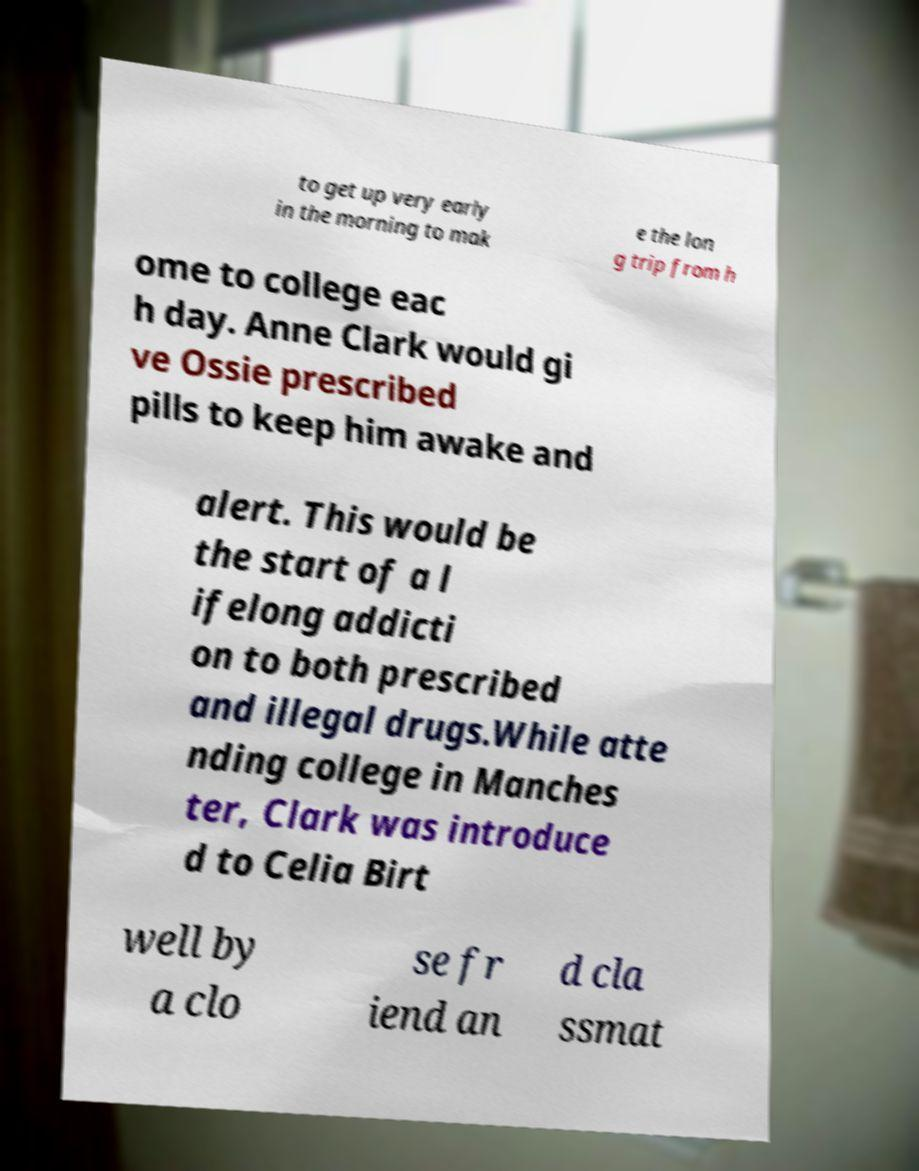Please read and relay the text visible in this image. What does it say? to get up very early in the morning to mak e the lon g trip from h ome to college eac h day. Anne Clark would gi ve Ossie prescribed pills to keep him awake and alert. This would be the start of a l ifelong addicti on to both prescribed and illegal drugs.While atte nding college in Manches ter, Clark was introduce d to Celia Birt well by a clo se fr iend an d cla ssmat 